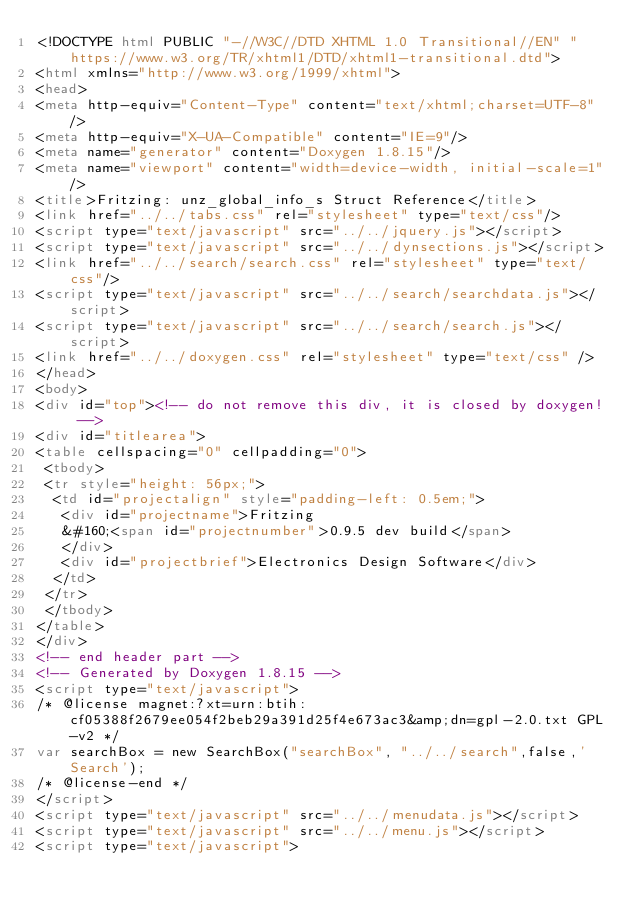Convert code to text. <code><loc_0><loc_0><loc_500><loc_500><_HTML_><!DOCTYPE html PUBLIC "-//W3C//DTD XHTML 1.0 Transitional//EN" "https://www.w3.org/TR/xhtml1/DTD/xhtml1-transitional.dtd">
<html xmlns="http://www.w3.org/1999/xhtml">
<head>
<meta http-equiv="Content-Type" content="text/xhtml;charset=UTF-8"/>
<meta http-equiv="X-UA-Compatible" content="IE=9"/>
<meta name="generator" content="Doxygen 1.8.15"/>
<meta name="viewport" content="width=device-width, initial-scale=1"/>
<title>Fritzing: unz_global_info_s Struct Reference</title>
<link href="../../tabs.css" rel="stylesheet" type="text/css"/>
<script type="text/javascript" src="../../jquery.js"></script>
<script type="text/javascript" src="../../dynsections.js"></script>
<link href="../../search/search.css" rel="stylesheet" type="text/css"/>
<script type="text/javascript" src="../../search/searchdata.js"></script>
<script type="text/javascript" src="../../search/search.js"></script>
<link href="../../doxygen.css" rel="stylesheet" type="text/css" />
</head>
<body>
<div id="top"><!-- do not remove this div, it is closed by doxygen! -->
<div id="titlearea">
<table cellspacing="0" cellpadding="0">
 <tbody>
 <tr style="height: 56px;">
  <td id="projectalign" style="padding-left: 0.5em;">
   <div id="projectname">Fritzing
   &#160;<span id="projectnumber">0.9.5 dev build</span>
   </div>
   <div id="projectbrief">Electronics Design Software</div>
  </td>
 </tr>
 </tbody>
</table>
</div>
<!-- end header part -->
<!-- Generated by Doxygen 1.8.15 -->
<script type="text/javascript">
/* @license magnet:?xt=urn:btih:cf05388f2679ee054f2beb29a391d25f4e673ac3&amp;dn=gpl-2.0.txt GPL-v2 */
var searchBox = new SearchBox("searchBox", "../../search",false,'Search');
/* @license-end */
</script>
<script type="text/javascript" src="../../menudata.js"></script>
<script type="text/javascript" src="../../menu.js"></script>
<script type="text/javascript"></code> 